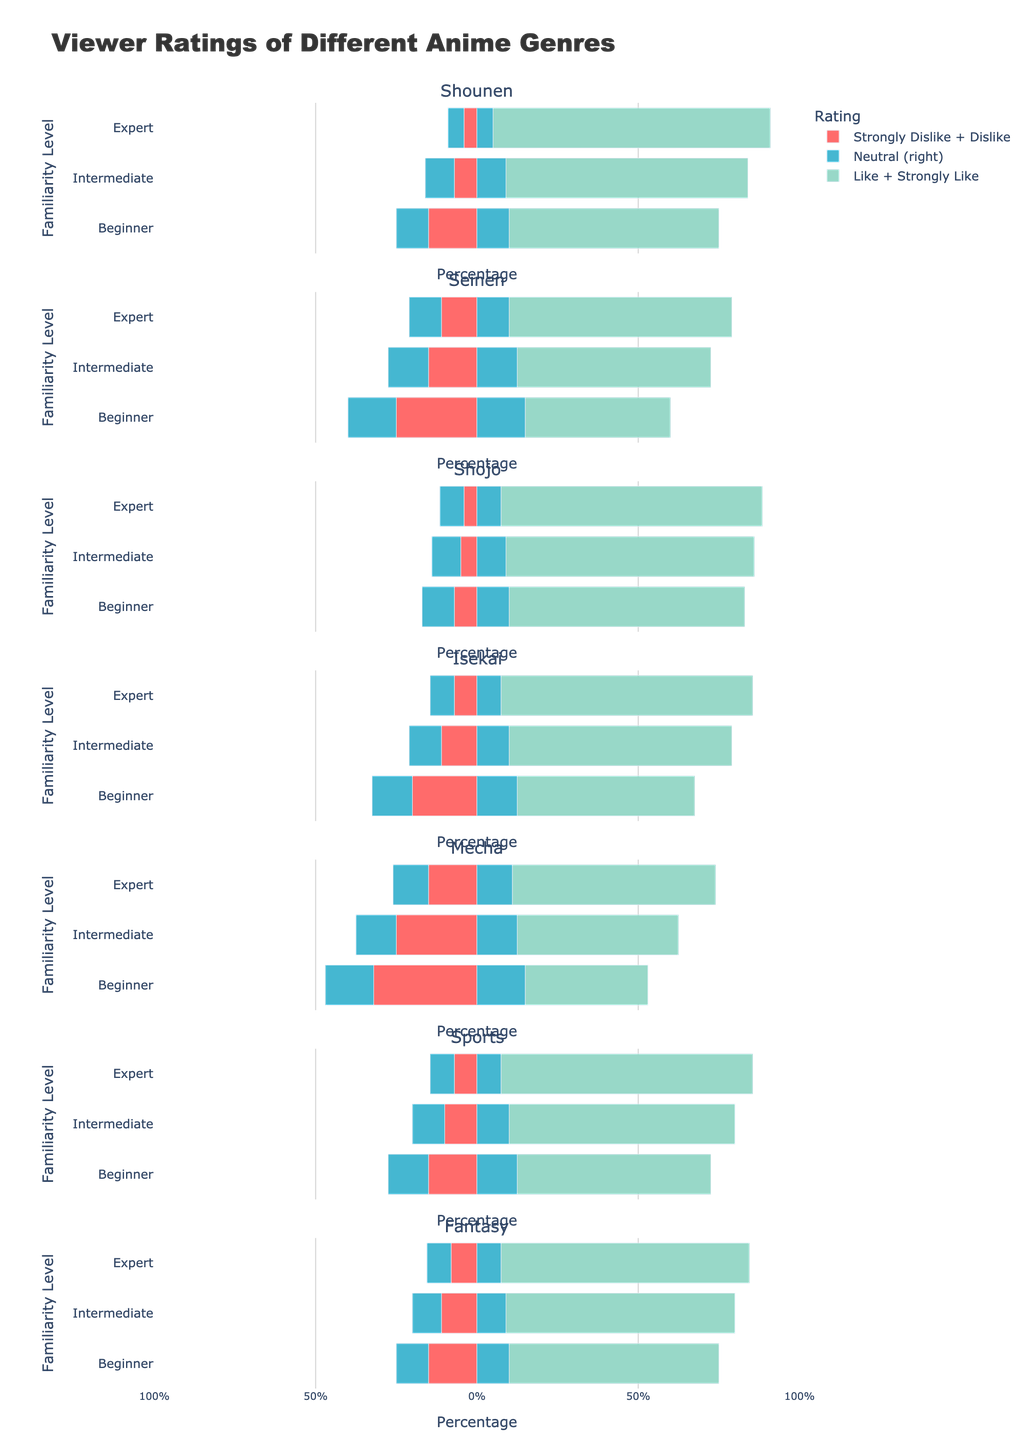Which genre has the highest percentage of 'Strongly Like' among experts? The bar lengths for 'Strongly Like' among experts should be checked for each genre to identify the tallest. Shounen has the highest percentage at 46%.
Answer: Shounen Which genre shows the largest positive difference in 'Like + Strongly Like' percentage between beginners and experts? Calculate the 'Like + Strongly Like' values for each genre at the beginner and expert levels. The difference for Shounen is (25+46) - (40+25) = 21%
Answer: Shounen Which familiarity level generally shows the least percentage of 'Strongly Dislike + Dislike' across all genres? Observe and compare the bar lengths for 'Strongly Dislike + Dislike' among beginners, intermediates, and experts across all genres. Experts generally have the shortest bars.
Answer: Expert For the genre Mecha, what is the percentage difference in 'Neutral' opinions between beginners and intermediates? Identify the 'Neutral' percentages for beginners and intermediates in Mecha. Difference: 30% (Beginners) - 25% (Intermediates) = 5%
Answer: 5% Which genre has the most polarized (highest sum of 'Strongly Dislike' and 'Strongly Like') viewer ratings among beginners? Check the lengths of 'Strongly Dislike' and 'Strongly Like' bars for all genres at the beginner level and sum them. Mecha: 12% + 13% = 25%
Answer: Mecha Compare the 'Strongly Like' percentages for Shojo between beginners and intermediates. Which familiarity level has a higher value and by how much? Identify 'Strongly Like' percentages for Shojo among beginners (23%) and intermediates (22%) and compute the difference. 23% - 22% = 1%
Answer: Beginner by 1% In the Isekai genre, which familiarity level shows the most balanced (closest to equal) 'Neutral' and 'Like' percentages? Compare 'Neutral' and 'Like' percentages for beginners, intermediates, and experts in Isekai. Beginners have 25% (Neutral) and 40% (Like), closest to balance.
Answer: Beginner In the genre Sports, what is the percentage increase in 'Like + Strongly Like' from beginners to experts? Calculate the values for beginners (45% + 15% = 60%) and experts (45% + 33% = 78%), then find the difference: 78% - 60% = 18%
Answer: 18% For the genre Fantasy, which familiarity level has the smallest sum of 'Dislike + Strongly Dislike' percentages? Check the percentages for each familiarity level in Fantasy and sum them. Experts: 2% + 6% = 8%
Answer: Expert Among all genres, which one has the highest 'Neutral' percentage for intermediates, and what is the value? Look for the genre with the tallest 'Neutral' bar for intermediates. Shojo has the highest at 18%.
Answer: Shojo, 18% 